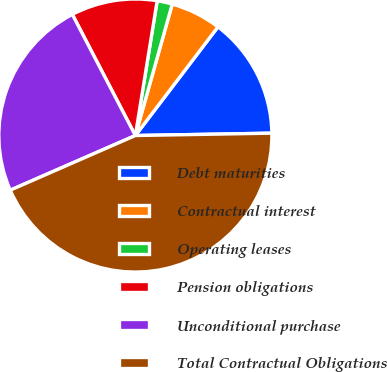Convert chart to OTSL. <chart><loc_0><loc_0><loc_500><loc_500><pie_chart><fcel>Debt maturities<fcel>Contractual interest<fcel>Operating leases<fcel>Pension obligations<fcel>Unconditional purchase<fcel>Total Contractual Obligations<nl><fcel>14.38%<fcel>5.99%<fcel>1.8%<fcel>10.19%<fcel>23.92%<fcel>43.72%<nl></chart> 